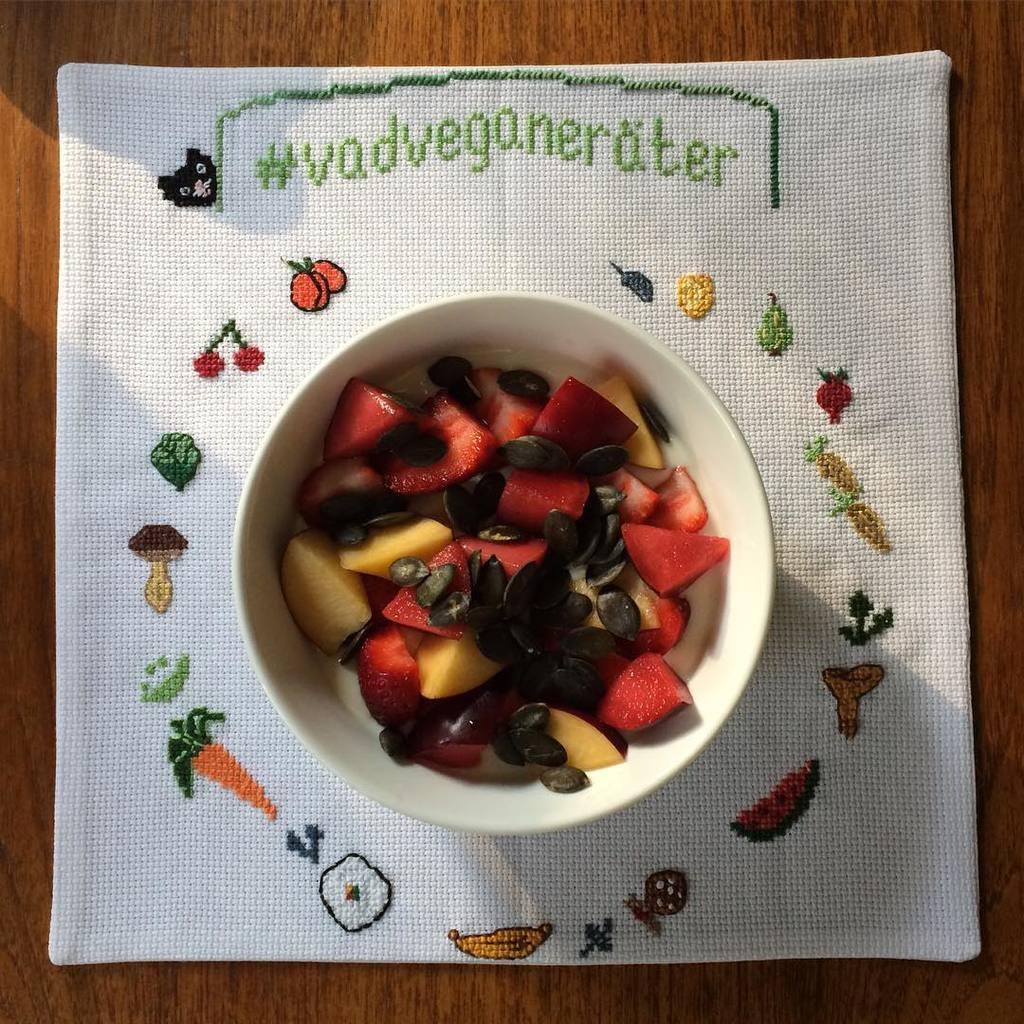Could you give a brief overview of what you see in this image? In this picture we can see fruits in the bowl, and we can find a cloth on the table. 